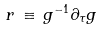<formula> <loc_0><loc_0><loc_500><loc_500>r \, \equiv \, g ^ { - 1 } \partial _ { \tau } g</formula> 